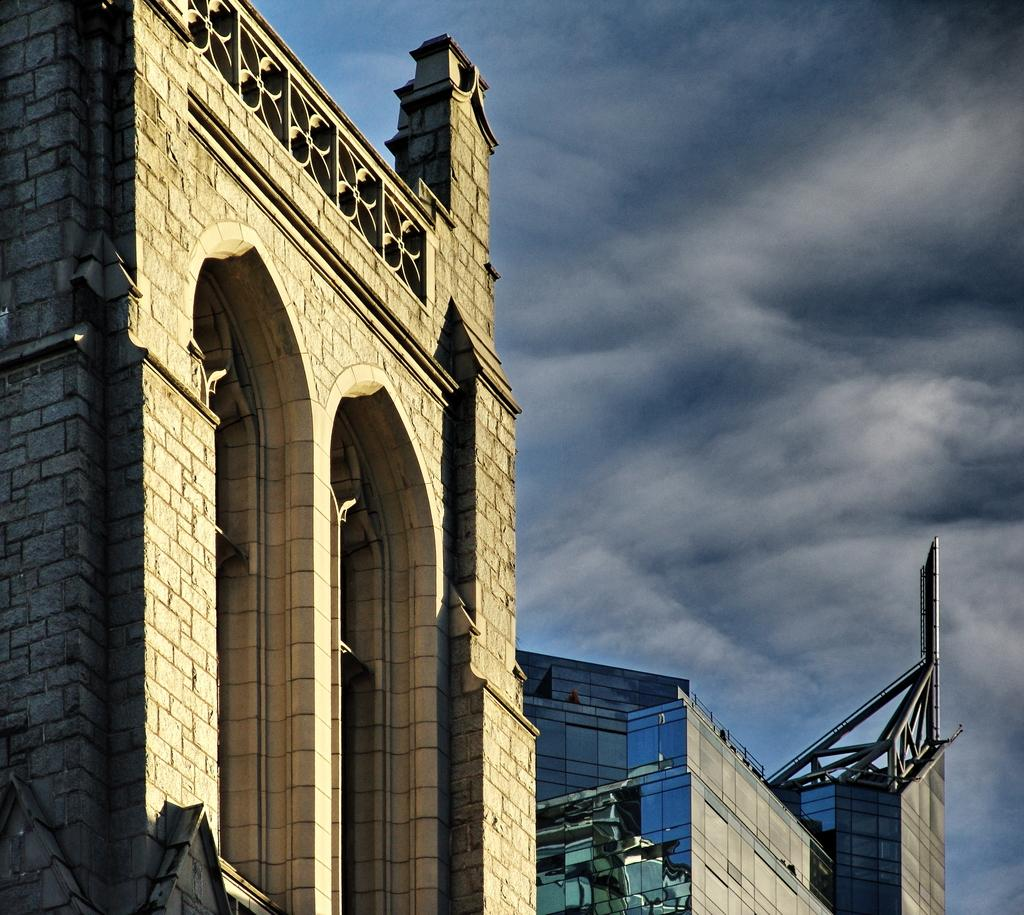What structures are present in the image? There are buildings in the image. What part of the natural environment is visible in the image? The sky is visible at the top of the image. What type of face can be seen on the buildings in the image? There are no faces present on the buildings in the image. What story is being told by the geese in the image? There are no geese present in the image, so no story can be told by them. 